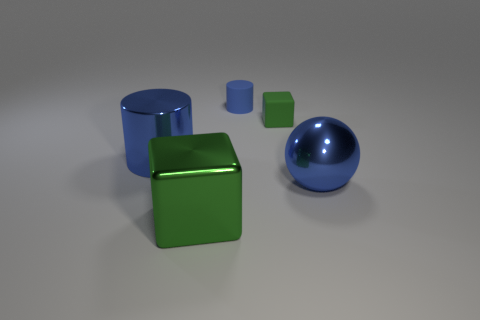Add 1 tiny brown metallic cylinders. How many objects exist? 6 Subtract all spheres. How many objects are left? 4 Add 3 large blue shiny things. How many large blue shiny things exist? 5 Subtract 1 blue cylinders. How many objects are left? 4 Subtract all green matte blocks. Subtract all small blue cylinders. How many objects are left? 3 Add 5 large green things. How many large green things are left? 6 